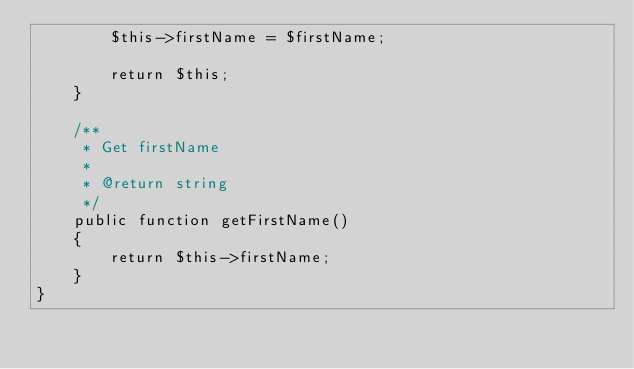<code> <loc_0><loc_0><loc_500><loc_500><_PHP_>        $this->firstName = $firstName;

        return $this;
    }

    /**
     * Get firstName
     *
     * @return string 
     */
    public function getFirstName()
    {
        return $this->firstName;
    }
}
</code> 